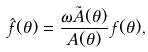<formula> <loc_0><loc_0><loc_500><loc_500>\hat { f } ( \theta ) = \frac { \omega \tilde { A } ( \theta ) } { A ( \theta ) } \, f ( \theta ) ,</formula> 